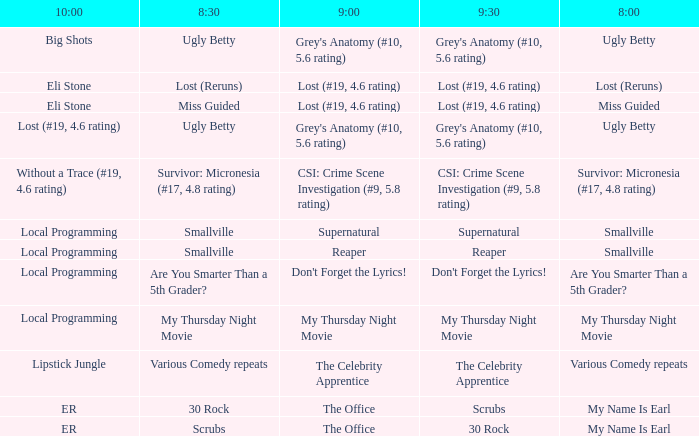What is at 10:00 when at 9:00 it is reaper? Local Programming. 